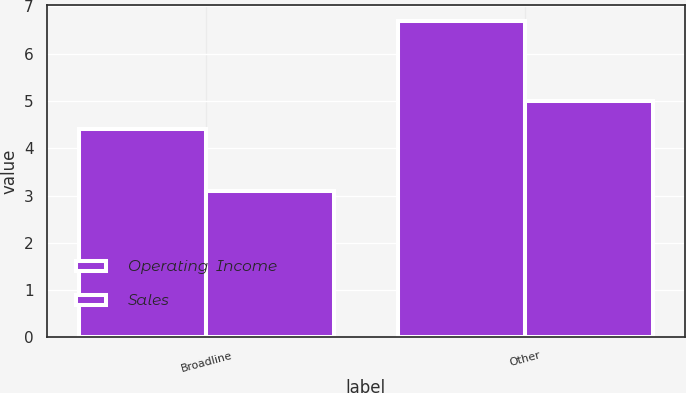Convert chart to OTSL. <chart><loc_0><loc_0><loc_500><loc_500><stacked_bar_chart><ecel><fcel>Broadline<fcel>Other<nl><fcel>Operating  Income<fcel>4.4<fcel>6.7<nl><fcel>Sales<fcel>3.1<fcel>5<nl></chart> 